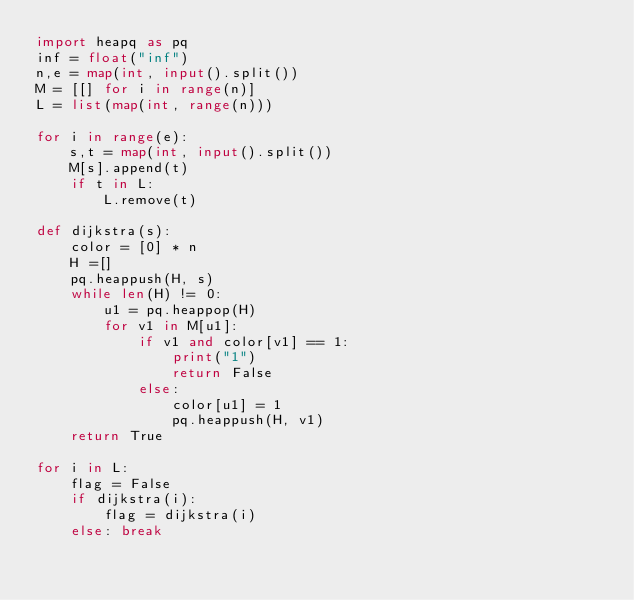<code> <loc_0><loc_0><loc_500><loc_500><_Python_>import heapq as pq
inf = float("inf")
n,e = map(int, input().split())
M = [[] for i in range(n)]
L = list(map(int, range(n)))

for i in range(e):
    s,t = map(int, input().split())
    M[s].append(t)
    if t in L:
        L.remove(t)
  
def dijkstra(s):
    color = [0] * n    
    H =[]
    pq.heappush(H, s)
    while len(H) != 0:
        u1 = pq.heappop(H)
        for v1 in M[u1]:
            if v1 and color[v1] == 1:
                print("1")
                return False
            else:
                color[u1] = 1
                pq.heappush(H, v1)
    return True

for i in L:
    flag = False
    if dijkstra(i):
        flag = dijkstra(i)
    else: break</code> 